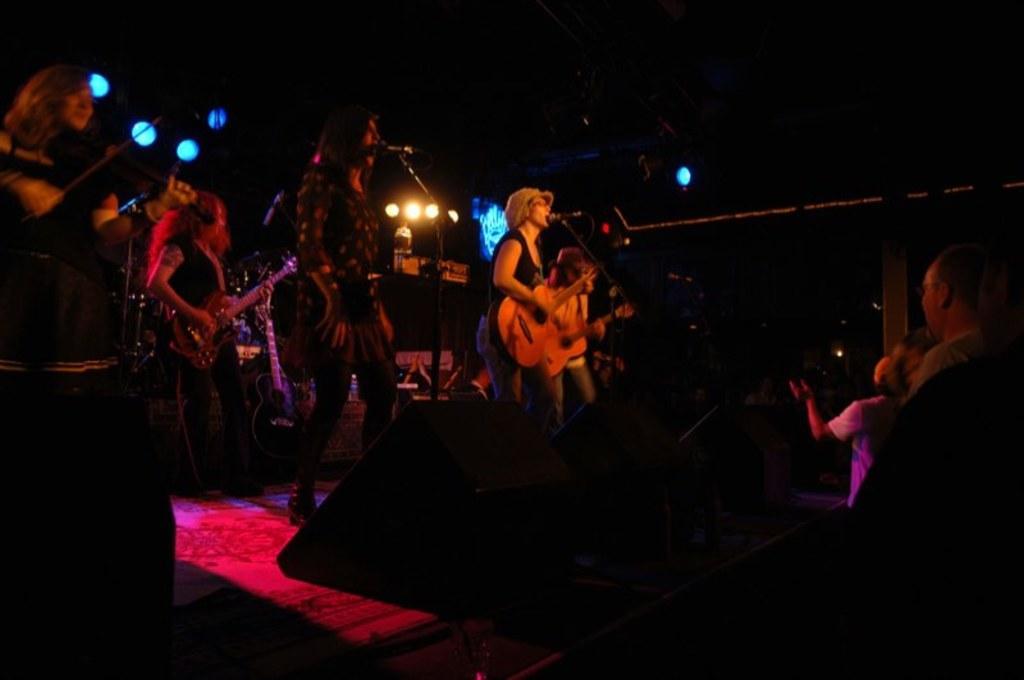Can you describe this image briefly? There are few people standing and singing song and playing guitars. These are the mike attached to their mic stands. I think this is a speaker. Here are few people standing and watching the performance. These are the show lights. I think this is the stage show,background is dark. 